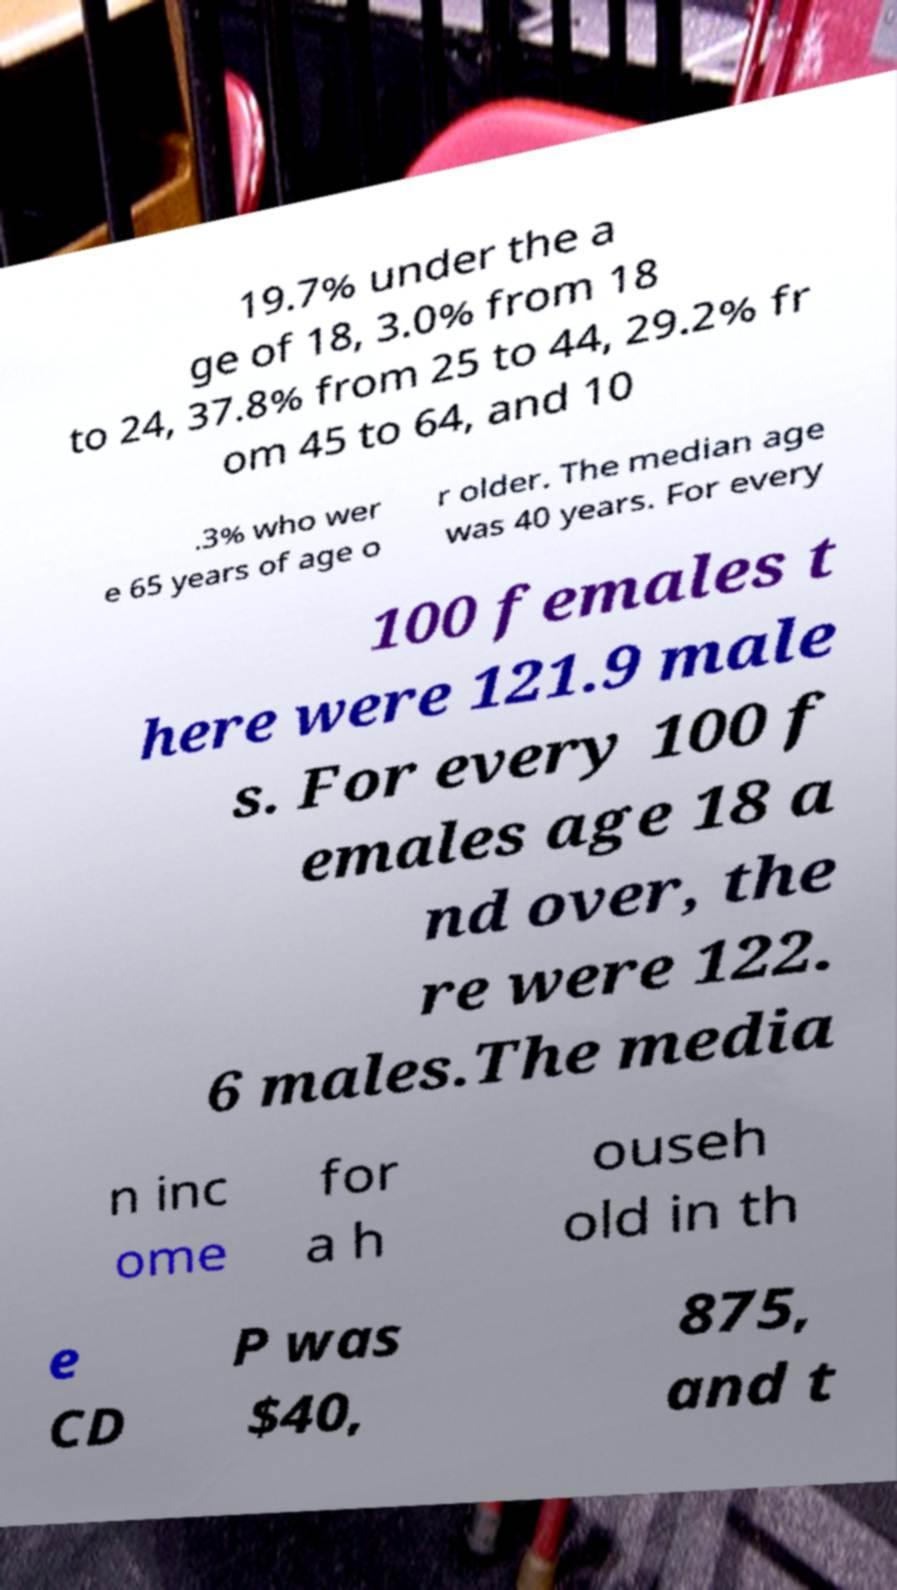I need the written content from this picture converted into text. Can you do that? 19.7% under the a ge of 18, 3.0% from 18 to 24, 37.8% from 25 to 44, 29.2% fr om 45 to 64, and 10 .3% who wer e 65 years of age o r older. The median age was 40 years. For every 100 females t here were 121.9 male s. For every 100 f emales age 18 a nd over, the re were 122. 6 males.The media n inc ome for a h ouseh old in th e CD P was $40, 875, and t 